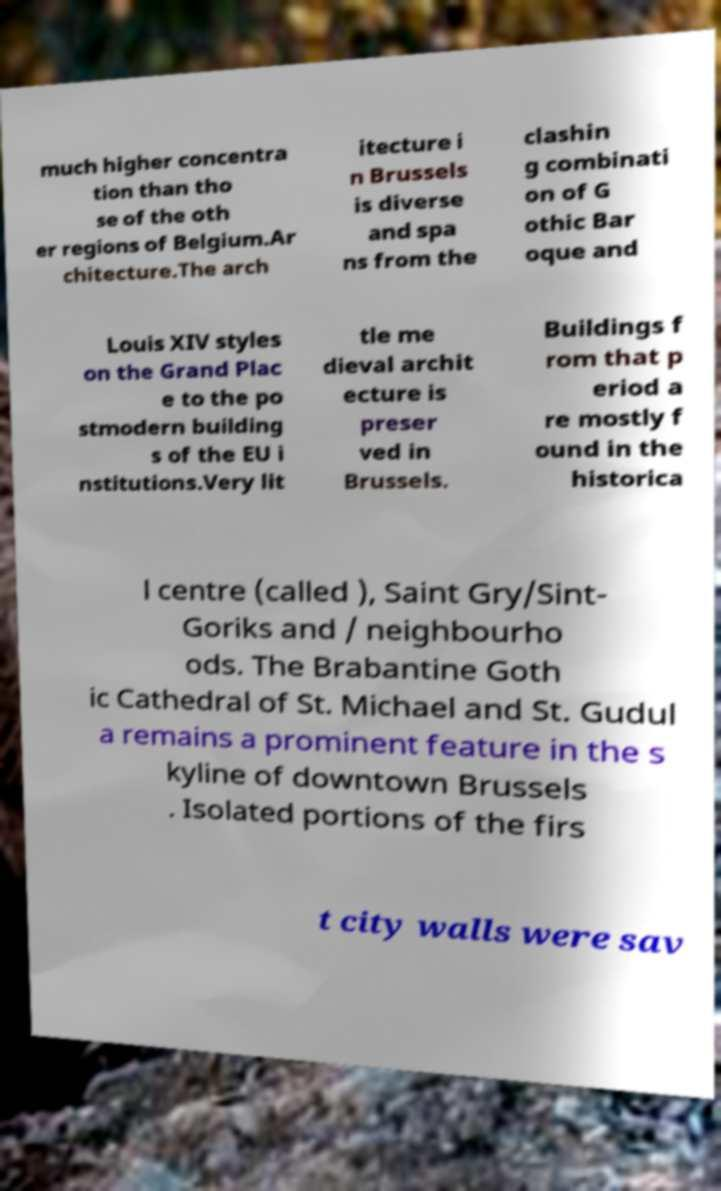Can you accurately transcribe the text from the provided image for me? much higher concentra tion than tho se of the oth er regions of Belgium.Ar chitecture.The arch itecture i n Brussels is diverse and spa ns from the clashin g combinati on of G othic Bar oque and Louis XIV styles on the Grand Plac e to the po stmodern building s of the EU i nstitutions.Very lit tle me dieval archit ecture is preser ved in Brussels. Buildings f rom that p eriod a re mostly f ound in the historica l centre (called ), Saint Gry/Sint- Goriks and / neighbourho ods. The Brabantine Goth ic Cathedral of St. Michael and St. Gudul a remains a prominent feature in the s kyline of downtown Brussels . Isolated portions of the firs t city walls were sav 